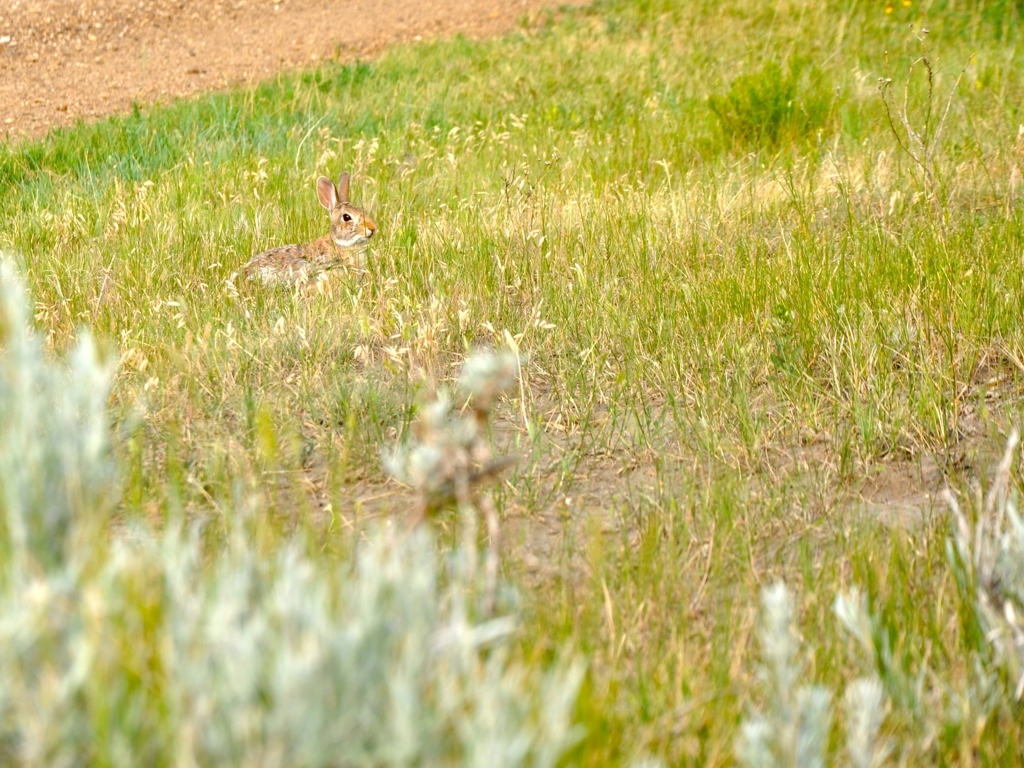How are the colors in the image? The colors in the image exhibit a natural and soothing palette, with verdant hues of green in the grasses dominating the scene. The rabbit's brown and white fur provides a gentle contrast to the surroundings, while the subtle touches of yellow from the scattered wildflowers add a hint of vibrancy to this serene natural setting. 